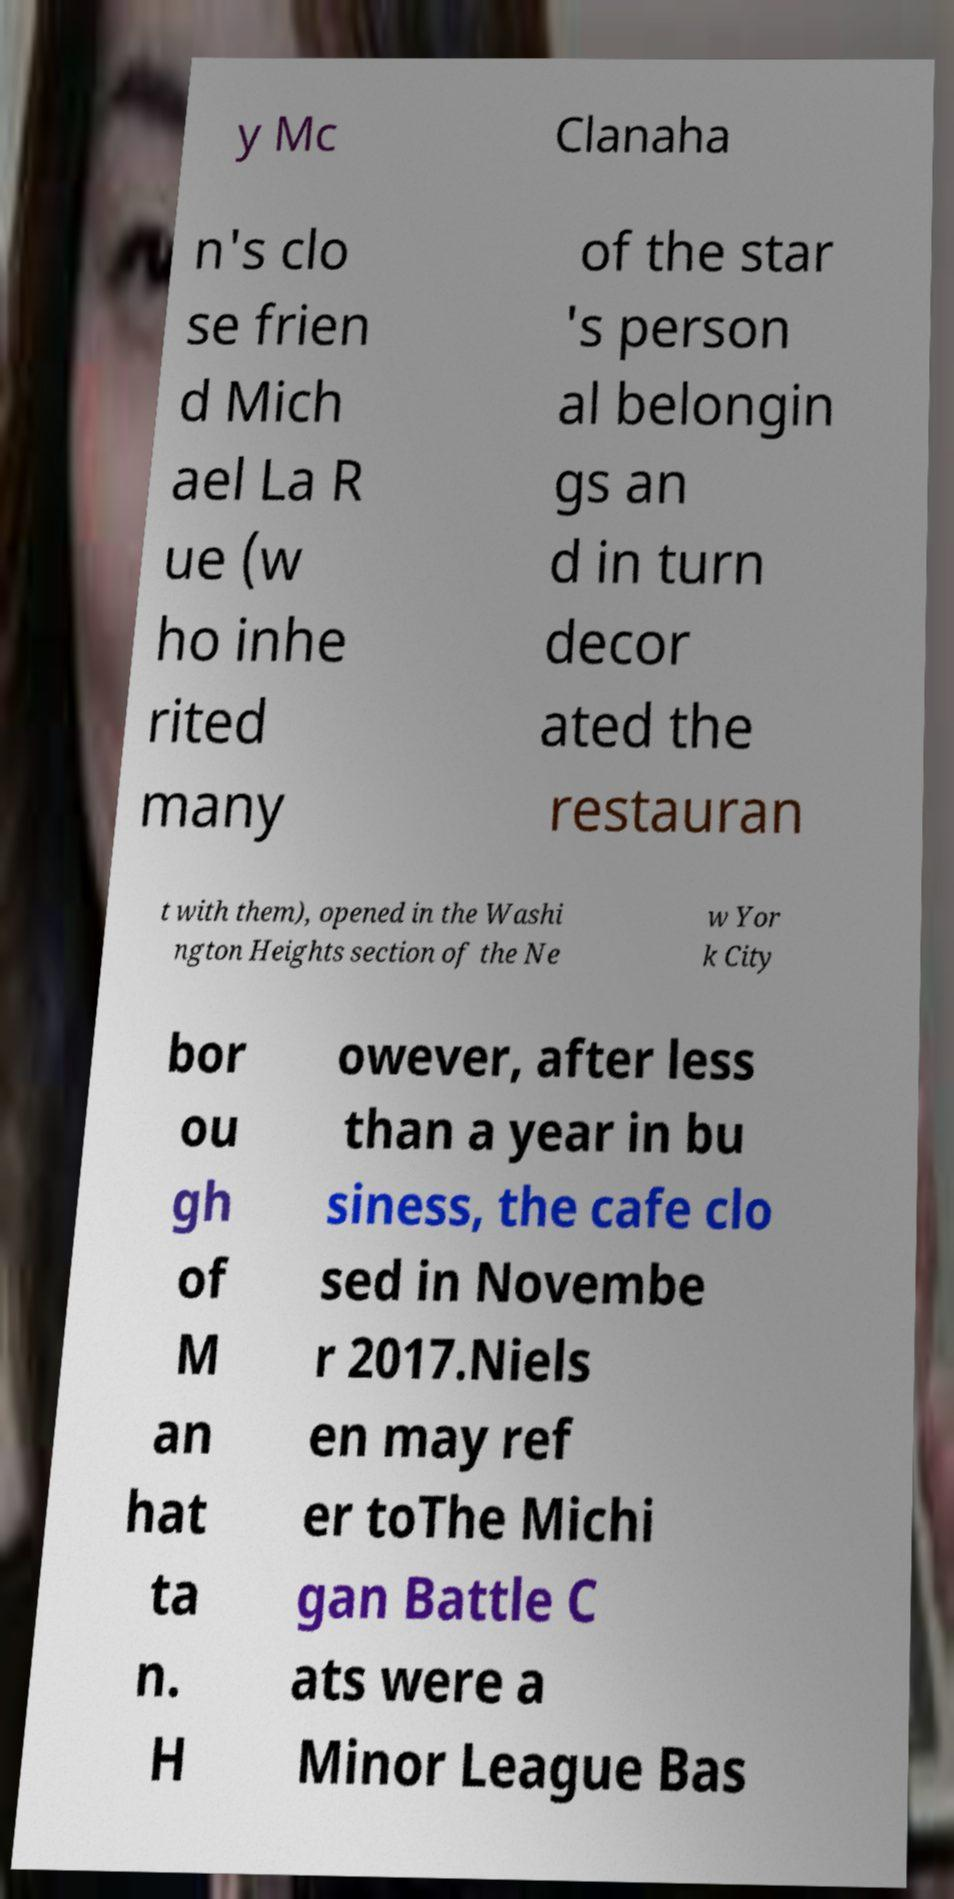Could you assist in decoding the text presented in this image and type it out clearly? y Mc Clanaha n's clo se frien d Mich ael La R ue (w ho inhe rited many of the star 's person al belongin gs an d in turn decor ated the restauran t with them), opened in the Washi ngton Heights section of the Ne w Yor k City bor ou gh of M an hat ta n. H owever, after less than a year in bu siness, the cafe clo sed in Novembe r 2017.Niels en may ref er toThe Michi gan Battle C ats were a Minor League Bas 